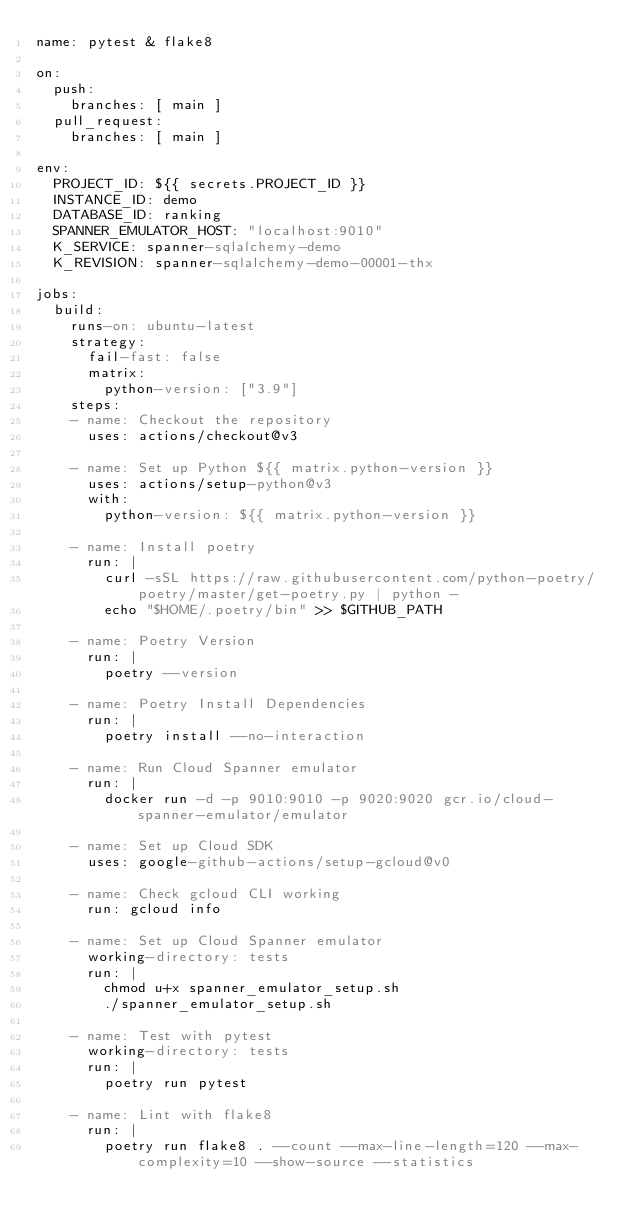<code> <loc_0><loc_0><loc_500><loc_500><_YAML_>name: pytest & flake8

on:
  push:
    branches: [ main ]
  pull_request:
    branches: [ main ]

env:
  PROJECT_ID: ${{ secrets.PROJECT_ID }}
  INSTANCE_ID: demo
  DATABASE_ID: ranking
  SPANNER_EMULATOR_HOST: "localhost:9010"
  K_SERVICE: spanner-sqlalchemy-demo
  K_REVISION: spanner-sqlalchemy-demo-00001-thx

jobs:
  build:
    runs-on: ubuntu-latest
    strategy:
      fail-fast: false
      matrix:
        python-version: ["3.9"]
    steps:
    - name: Checkout the repository
      uses: actions/checkout@v3

    - name: Set up Python ${{ matrix.python-version }}
      uses: actions/setup-python@v3
      with:
        python-version: ${{ matrix.python-version }}

    - name: Install poetry
      run: |
        curl -sSL https://raw.githubusercontent.com/python-poetry/poetry/master/get-poetry.py | python -
        echo "$HOME/.poetry/bin" >> $GITHUB_PATH

    - name: Poetry Version
      run: |
        poetry --version

    - name: Poetry Install Dependencies
      run: |
        poetry install --no-interaction

    - name: Run Cloud Spanner emulator
      run: |
        docker run -d -p 9010:9010 -p 9020:9020 gcr.io/cloud-spanner-emulator/emulator

    - name: Set up Cloud SDK
      uses: google-github-actions/setup-gcloud@v0

    - name: Check gcloud CLI working
      run: gcloud info

    - name: Set up Cloud Spanner emulator
      working-directory: tests
      run: |
        chmod u+x spanner_emulator_setup.sh
        ./spanner_emulator_setup.sh

    - name: Test with pytest
      working-directory: tests
      run: |
        poetry run pytest

    - name: Lint with flake8
      run: |
        poetry run flake8 . --count --max-line-length=120 --max-complexity=10 --show-source --statistics
</code> 